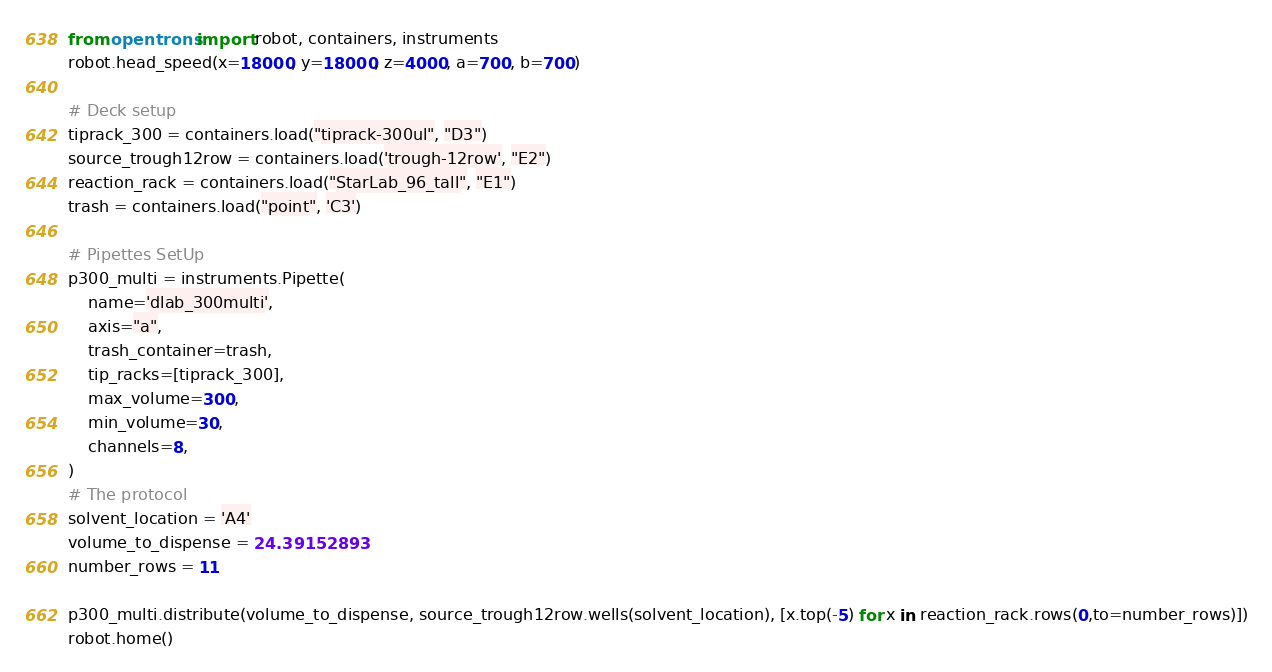Convert code to text. <code><loc_0><loc_0><loc_500><loc_500><_Python_>from opentrons import robot, containers, instruments
robot.head_speed(x=18000, y=18000, z=4000, a=700, b=700)

# Deck setup
tiprack_300 = containers.load("tiprack-300ul", "D3")
source_trough12row = containers.load('trough-12row', "E2")
reaction_rack = containers.load("StarLab_96_tall", "E1")
trash = containers.load("point", 'C3')

# Pipettes SetUp
p300_multi = instruments.Pipette(
    name='dlab_300multi',
    axis="a",
    trash_container=trash,
    tip_racks=[tiprack_300],
    max_volume=300,
    min_volume=30,
    channels=8,
)
# The protocol
solvent_location = 'A4'
volume_to_dispense = 24.39152893
number_rows = 11

p300_multi.distribute(volume_to_dispense, source_trough12row.wells(solvent_location), [x.top(-5) for x in reaction_rack.rows(0,to=number_rows)])
robot.home()
</code> 